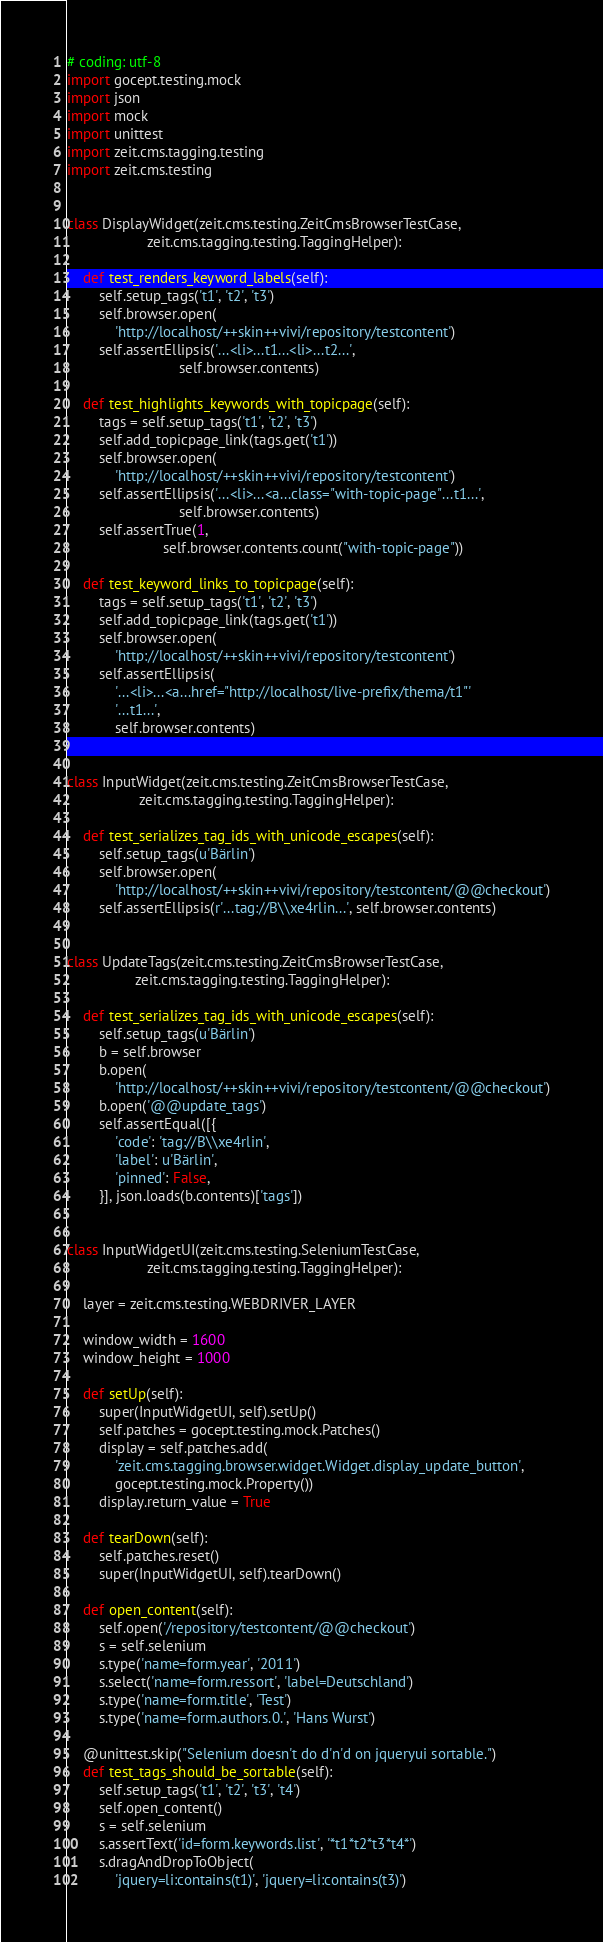Convert code to text. <code><loc_0><loc_0><loc_500><loc_500><_Python_># coding: utf-8
import gocept.testing.mock
import json
import mock
import unittest
import zeit.cms.tagging.testing
import zeit.cms.testing


class DisplayWidget(zeit.cms.testing.ZeitCmsBrowserTestCase,
                    zeit.cms.tagging.testing.TaggingHelper):

    def test_renders_keyword_labels(self):
        self.setup_tags('t1', 't2', 't3')
        self.browser.open(
            'http://localhost/++skin++vivi/repository/testcontent')
        self.assertEllipsis('...<li>...t1...<li>...t2...',
                            self.browser.contents)

    def test_highlights_keywords_with_topicpage(self):
        tags = self.setup_tags('t1', 't2', 't3')
        self.add_topicpage_link(tags.get('t1'))
        self.browser.open(
            'http://localhost/++skin++vivi/repository/testcontent')
        self.assertEllipsis('...<li>...<a...class="with-topic-page"...t1...',
                            self.browser.contents)
        self.assertTrue(1,
                        self.browser.contents.count("with-topic-page"))

    def test_keyword_links_to_topicpage(self):
        tags = self.setup_tags('t1', 't2', 't3')
        self.add_topicpage_link(tags.get('t1'))
        self.browser.open(
            'http://localhost/++skin++vivi/repository/testcontent')
        self.assertEllipsis(
            '...<li>...<a...href="http://localhost/live-prefix/thema/t1"'
            '...t1...',
            self.browser.contents)


class InputWidget(zeit.cms.testing.ZeitCmsBrowserTestCase,
                  zeit.cms.tagging.testing.TaggingHelper):

    def test_serializes_tag_ids_with_unicode_escapes(self):
        self.setup_tags(u'Bärlin')
        self.browser.open(
            'http://localhost/++skin++vivi/repository/testcontent/@@checkout')
        self.assertEllipsis(r'...tag://B\\xe4rlin...', self.browser.contents)


class UpdateTags(zeit.cms.testing.ZeitCmsBrowserTestCase,
                 zeit.cms.tagging.testing.TaggingHelper):

    def test_serializes_tag_ids_with_unicode_escapes(self):
        self.setup_tags(u'Bärlin')
        b = self.browser
        b.open(
            'http://localhost/++skin++vivi/repository/testcontent/@@checkout')
        b.open('@@update_tags')
        self.assertEqual([{
            'code': 'tag://B\\xe4rlin',
            'label': u'Bärlin',
            'pinned': False,
        }], json.loads(b.contents)['tags'])


class InputWidgetUI(zeit.cms.testing.SeleniumTestCase,
                    zeit.cms.tagging.testing.TaggingHelper):

    layer = zeit.cms.testing.WEBDRIVER_LAYER

    window_width = 1600
    window_height = 1000

    def setUp(self):
        super(InputWidgetUI, self).setUp()
        self.patches = gocept.testing.mock.Patches()
        display = self.patches.add(
            'zeit.cms.tagging.browser.widget.Widget.display_update_button',
            gocept.testing.mock.Property())
        display.return_value = True

    def tearDown(self):
        self.patches.reset()
        super(InputWidgetUI, self).tearDown()

    def open_content(self):
        self.open('/repository/testcontent/@@checkout')
        s = self.selenium
        s.type('name=form.year', '2011')
        s.select('name=form.ressort', 'label=Deutschland')
        s.type('name=form.title', 'Test')
        s.type('name=form.authors.0.', 'Hans Wurst')

    @unittest.skip("Selenium doesn't do d'n'd on jqueryui sortable.")
    def test_tags_should_be_sortable(self):
        self.setup_tags('t1', 't2', 't3', 't4')
        self.open_content()
        s = self.selenium
        s.assertText('id=form.keywords.list', '*t1*t2*t3*t4*')
        s.dragAndDropToObject(
            'jquery=li:contains(t1)', 'jquery=li:contains(t3)')</code> 